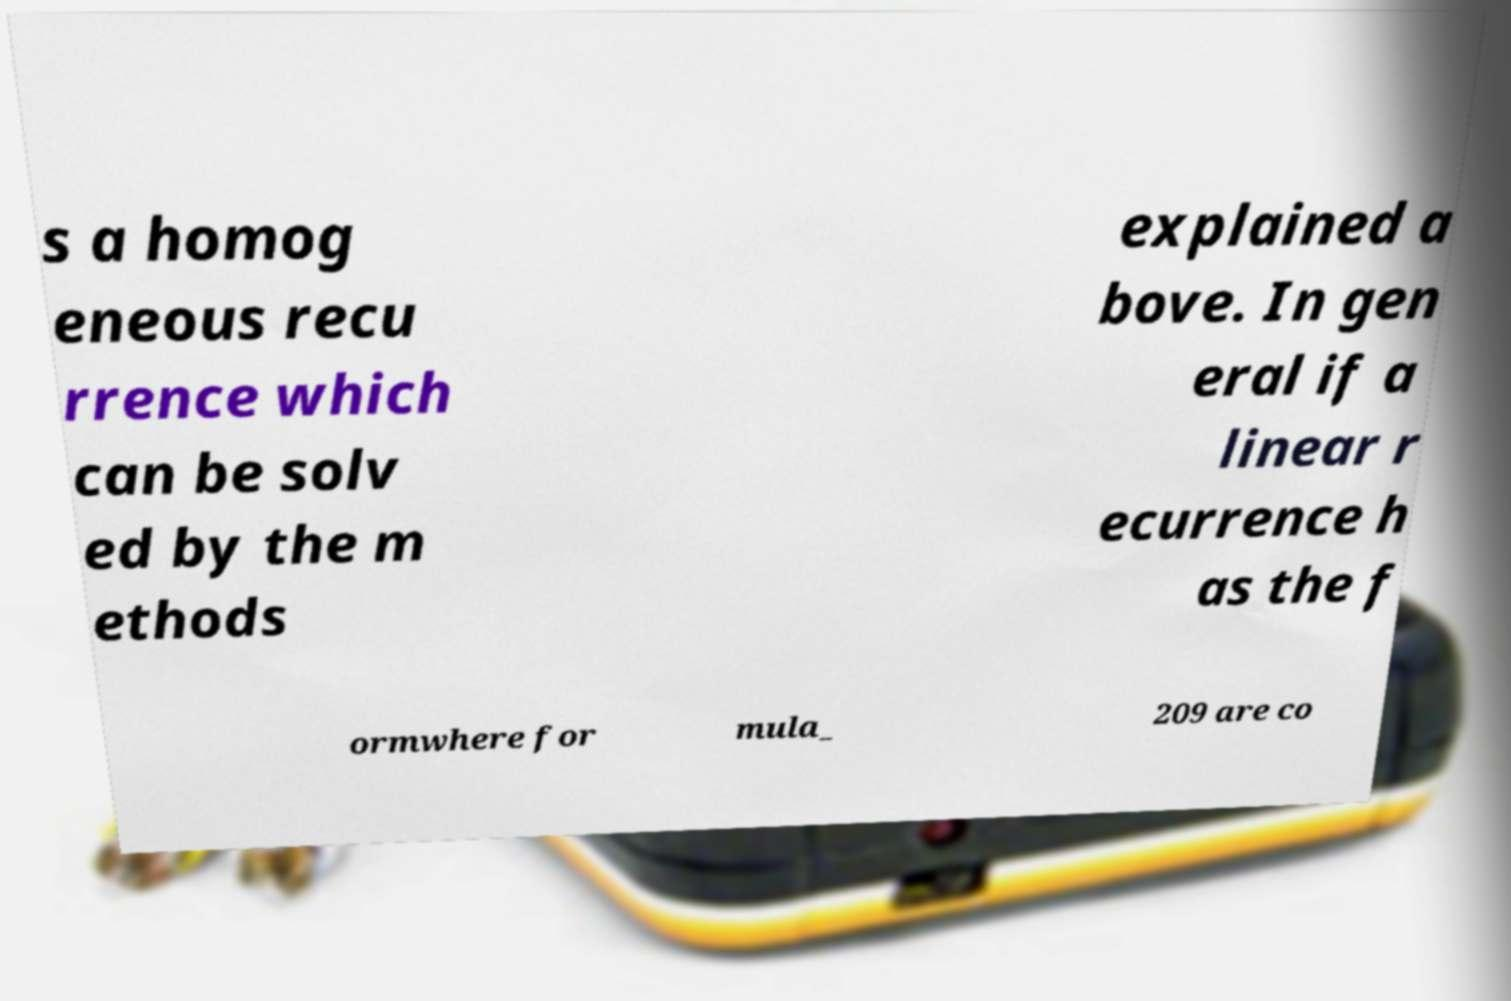Could you assist in decoding the text presented in this image and type it out clearly? s a homog eneous recu rrence which can be solv ed by the m ethods explained a bove. In gen eral if a linear r ecurrence h as the f ormwhere for mula_ 209 are co 